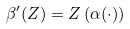Convert formula to latex. <formula><loc_0><loc_0><loc_500><loc_500>\beta ^ { \prime } ( Z ) = Z \left ( \alpha ( \cdot ) \right )</formula> 